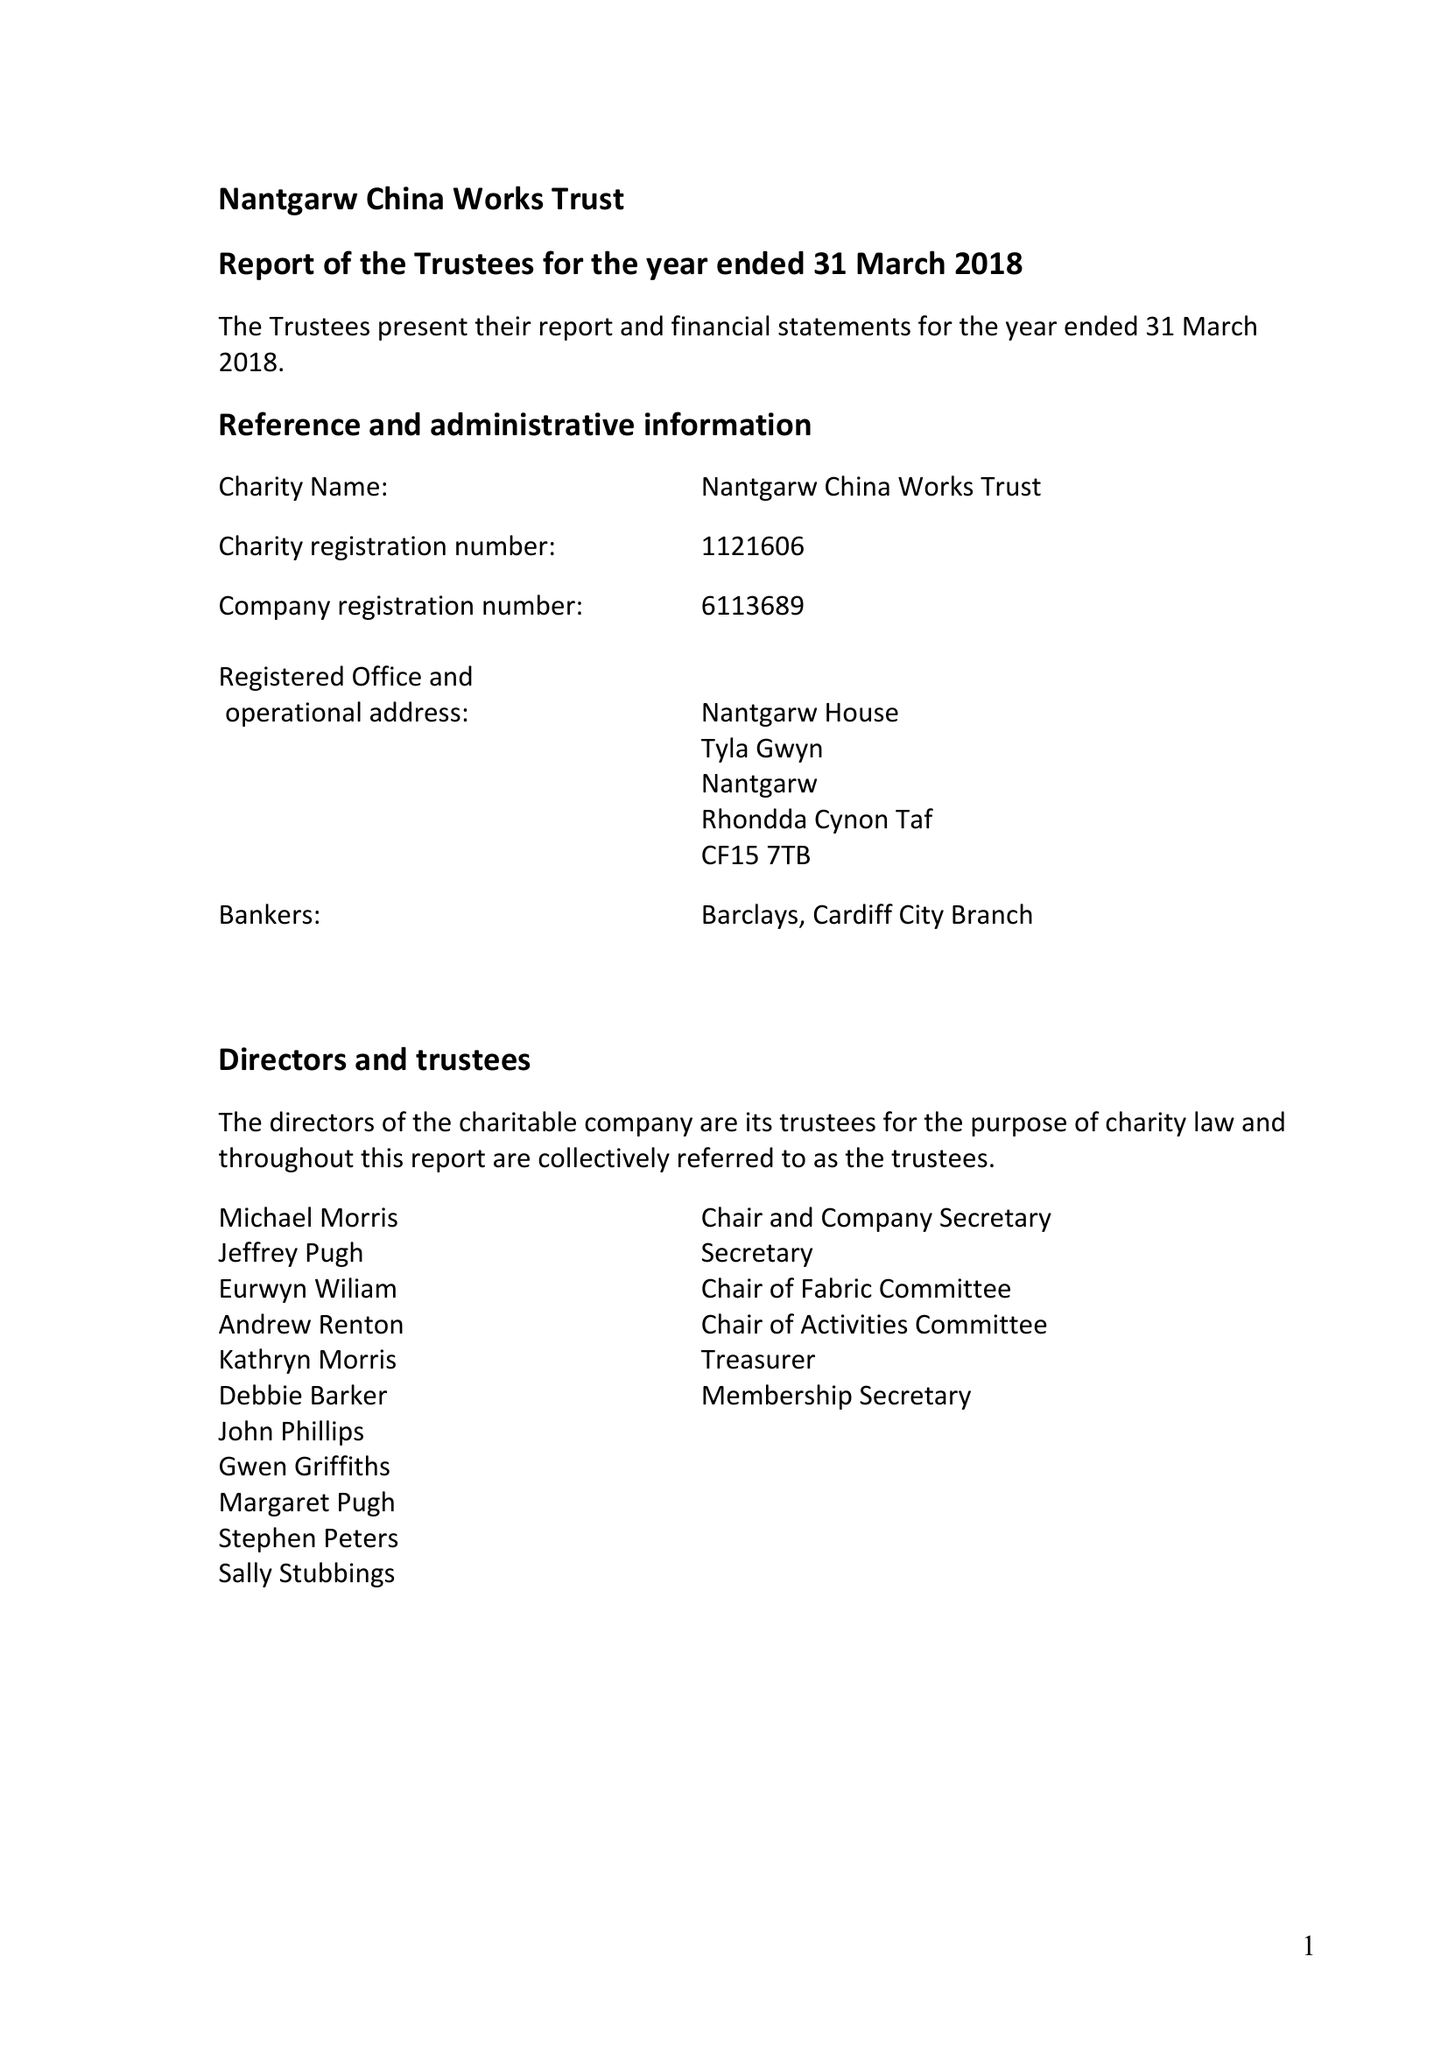What is the value for the charity_name?
Answer the question using a single word or phrase. Nantgarw China Works Trust 